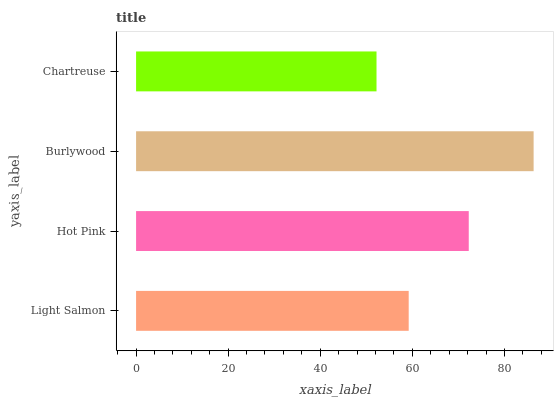Is Chartreuse the minimum?
Answer yes or no. Yes. Is Burlywood the maximum?
Answer yes or no. Yes. Is Hot Pink the minimum?
Answer yes or no. No. Is Hot Pink the maximum?
Answer yes or no. No. Is Hot Pink greater than Light Salmon?
Answer yes or no. Yes. Is Light Salmon less than Hot Pink?
Answer yes or no. Yes. Is Light Salmon greater than Hot Pink?
Answer yes or no. No. Is Hot Pink less than Light Salmon?
Answer yes or no. No. Is Hot Pink the high median?
Answer yes or no. Yes. Is Light Salmon the low median?
Answer yes or no. Yes. Is Light Salmon the high median?
Answer yes or no. No. Is Hot Pink the low median?
Answer yes or no. No. 